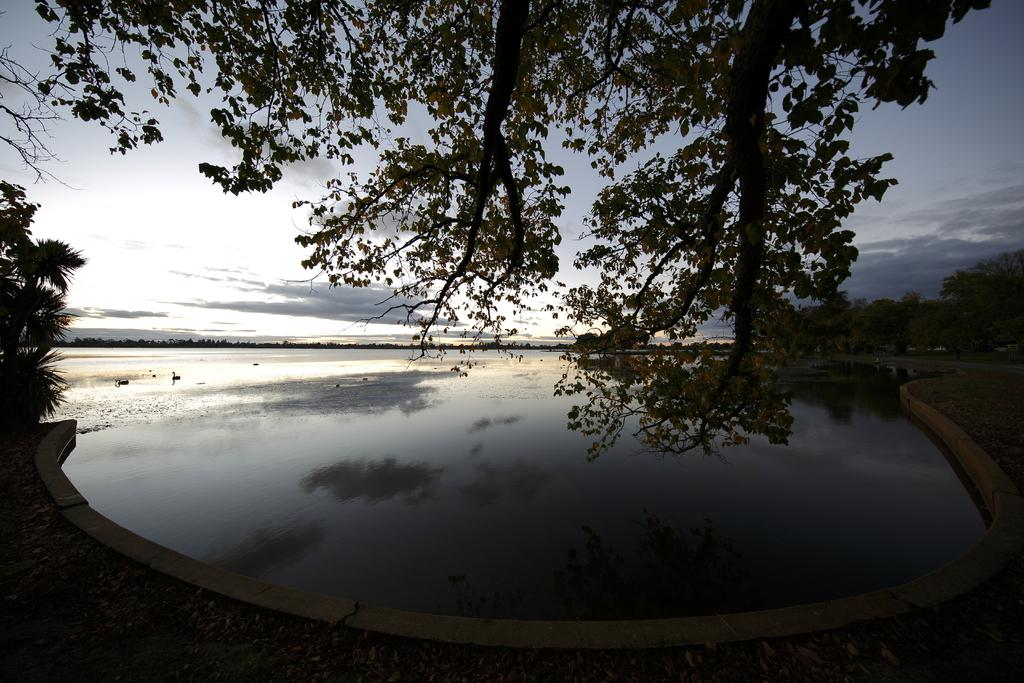What type of vegetation can be seen in the image? There are trees in the image. What natural element is visible besides the trees? There is water visible in the image. What can be seen in the background of the image? The sky is visible in the background of the image. What is the tendency of the trees to sort themselves in the image? There is no indication of the trees sorting themselves in the image, as trees do not have the ability to sort themselves. 